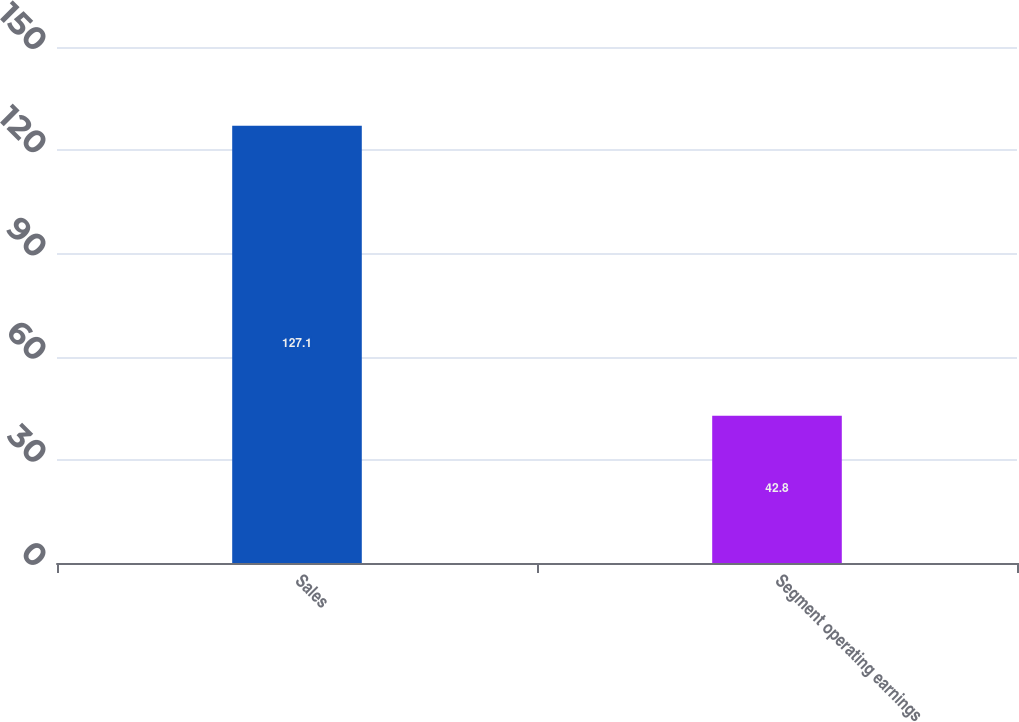Convert chart to OTSL. <chart><loc_0><loc_0><loc_500><loc_500><bar_chart><fcel>Sales<fcel>Segment operating earnings<nl><fcel>127.1<fcel>42.8<nl></chart> 